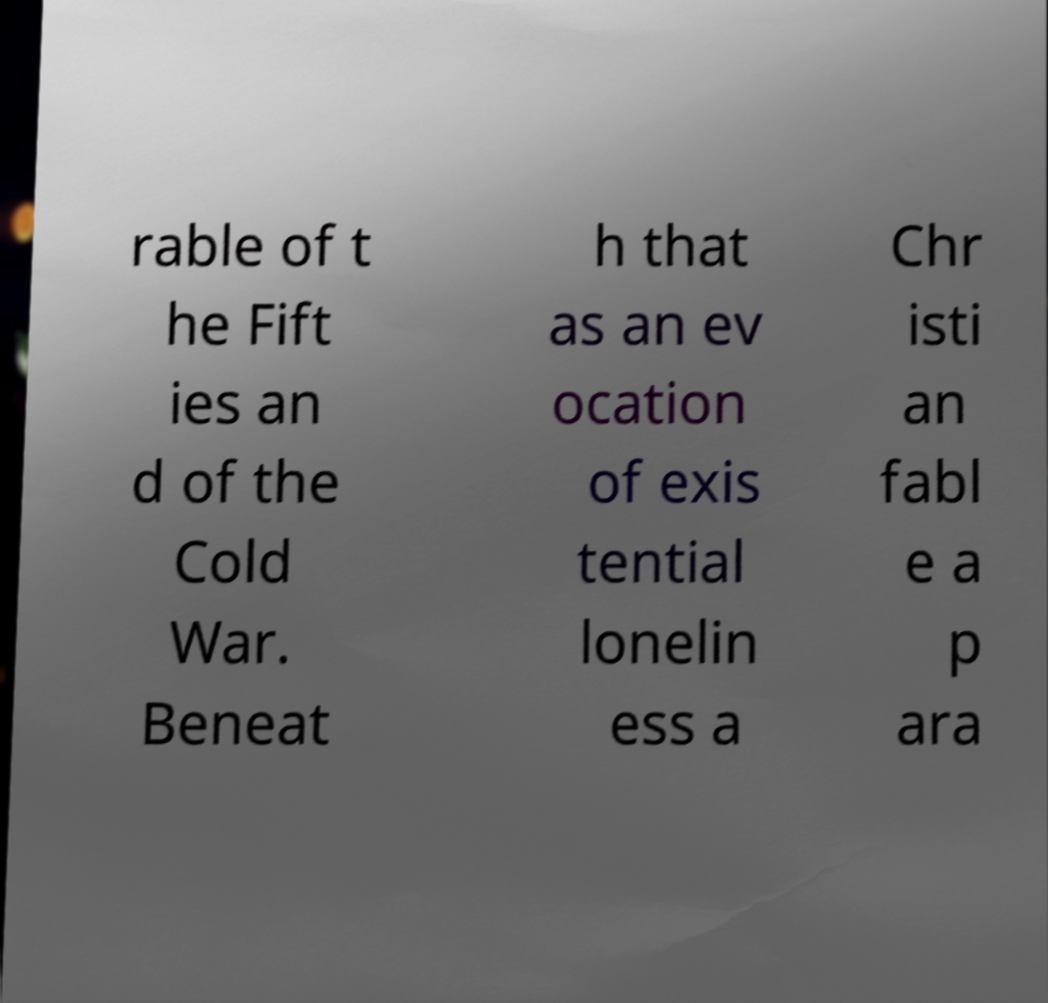Please identify and transcribe the text found in this image. rable of t he Fift ies an d of the Cold War. Beneat h that as an ev ocation of exis tential lonelin ess a Chr isti an fabl e a p ara 